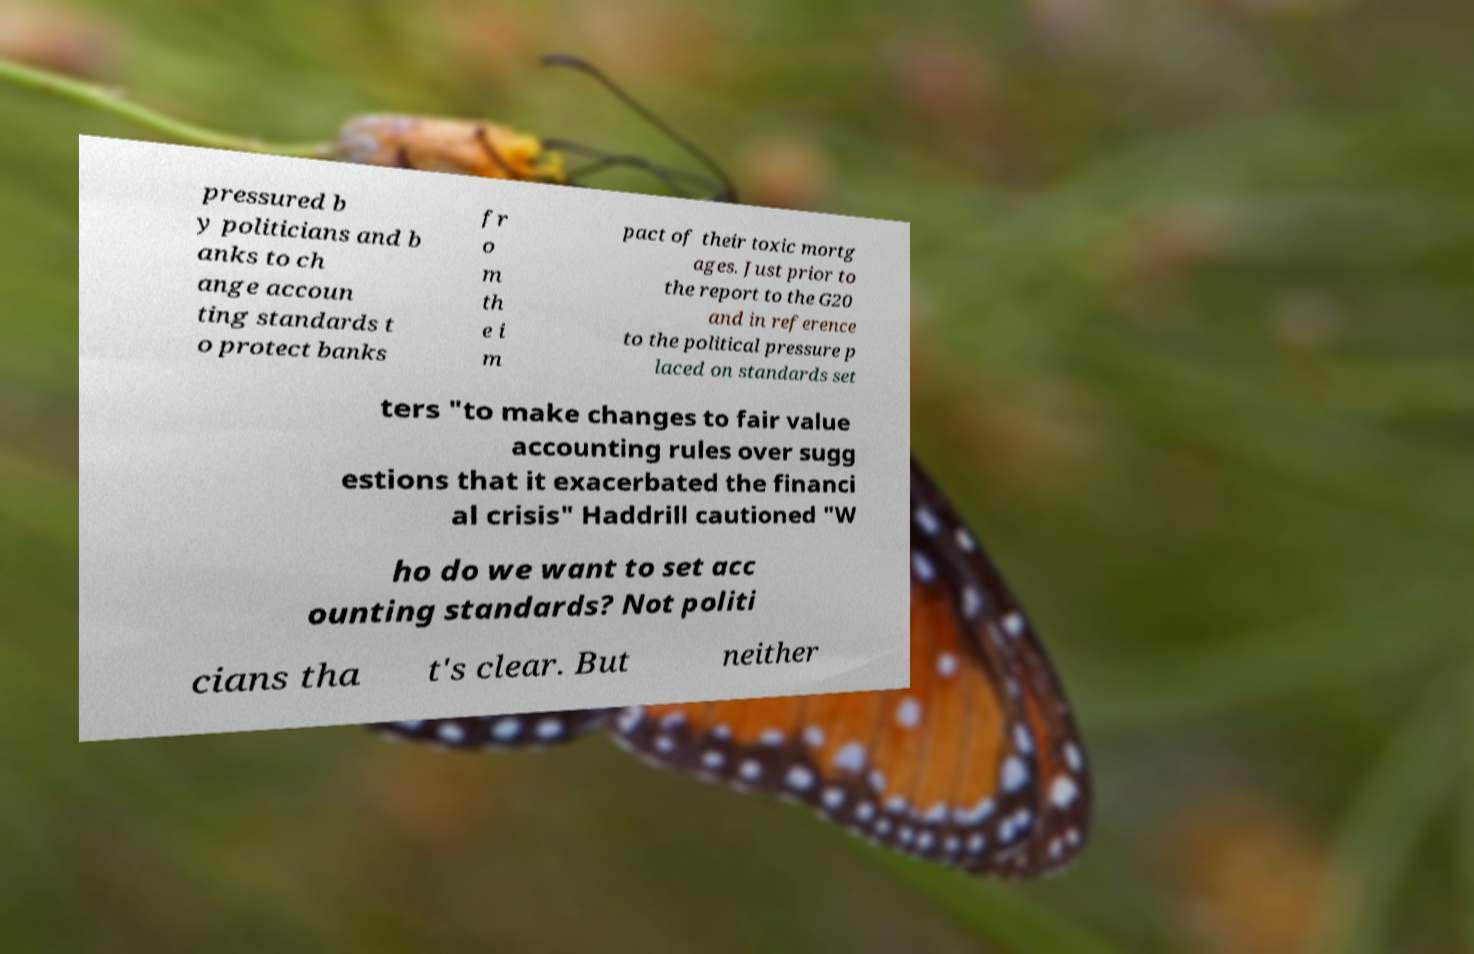Can you read and provide the text displayed in the image?This photo seems to have some interesting text. Can you extract and type it out for me? pressured b y politicians and b anks to ch ange accoun ting standards t o protect banks fr o m th e i m pact of their toxic mortg ages. Just prior to the report to the G20 and in reference to the political pressure p laced on standards set ters "to make changes to fair value accounting rules over sugg estions that it exacerbated the financi al crisis" Haddrill cautioned "W ho do we want to set acc ounting standards? Not politi cians tha t's clear. But neither 